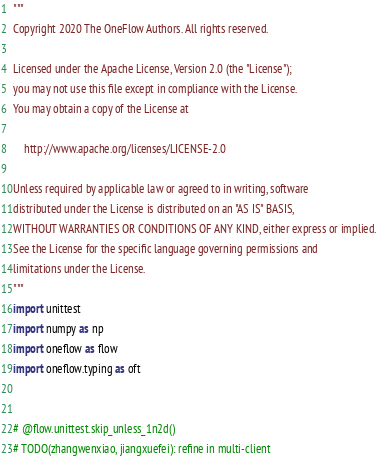<code> <loc_0><loc_0><loc_500><loc_500><_Python_>"""
Copyright 2020 The OneFlow Authors. All rights reserved.

Licensed under the Apache License, Version 2.0 (the "License");
you may not use this file except in compliance with the License.
You may obtain a copy of the License at

    http://www.apache.org/licenses/LICENSE-2.0

Unless required by applicable law or agreed to in writing, software
distributed under the License is distributed on an "AS IS" BASIS,
WITHOUT WARRANTIES OR CONDITIONS OF ANY KIND, either express or implied.
See the License for the specific language governing permissions and
limitations under the License.
"""
import unittest
import numpy as np
import oneflow as flow
import oneflow.typing as oft


# @flow.unittest.skip_unless_1n2d()
# TODO(zhangwenxiao, jiangxuefei): refine in multi-client</code> 